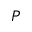Convert formula to latex. <formula><loc_0><loc_0><loc_500><loc_500>P</formula> 